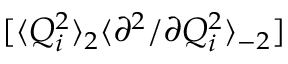Convert formula to latex. <formula><loc_0><loc_0><loc_500><loc_500>[ \langle Q _ { i } ^ { 2 } \rangle _ { 2 } \langle { \partial ^ { 2 } } / { \partial Q _ { i } ^ { 2 } } \rangle _ { - 2 } ]</formula> 